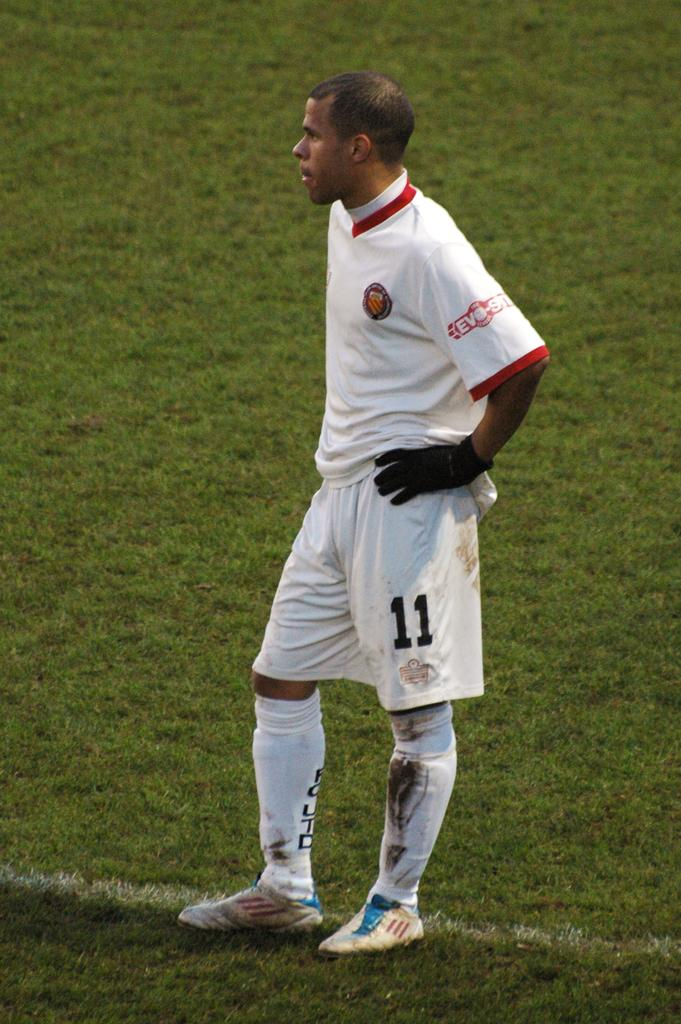<image>
Create a compact narrative representing the image presented. A player wearing number 11 on his shorts stand on the field with mud on his socks 